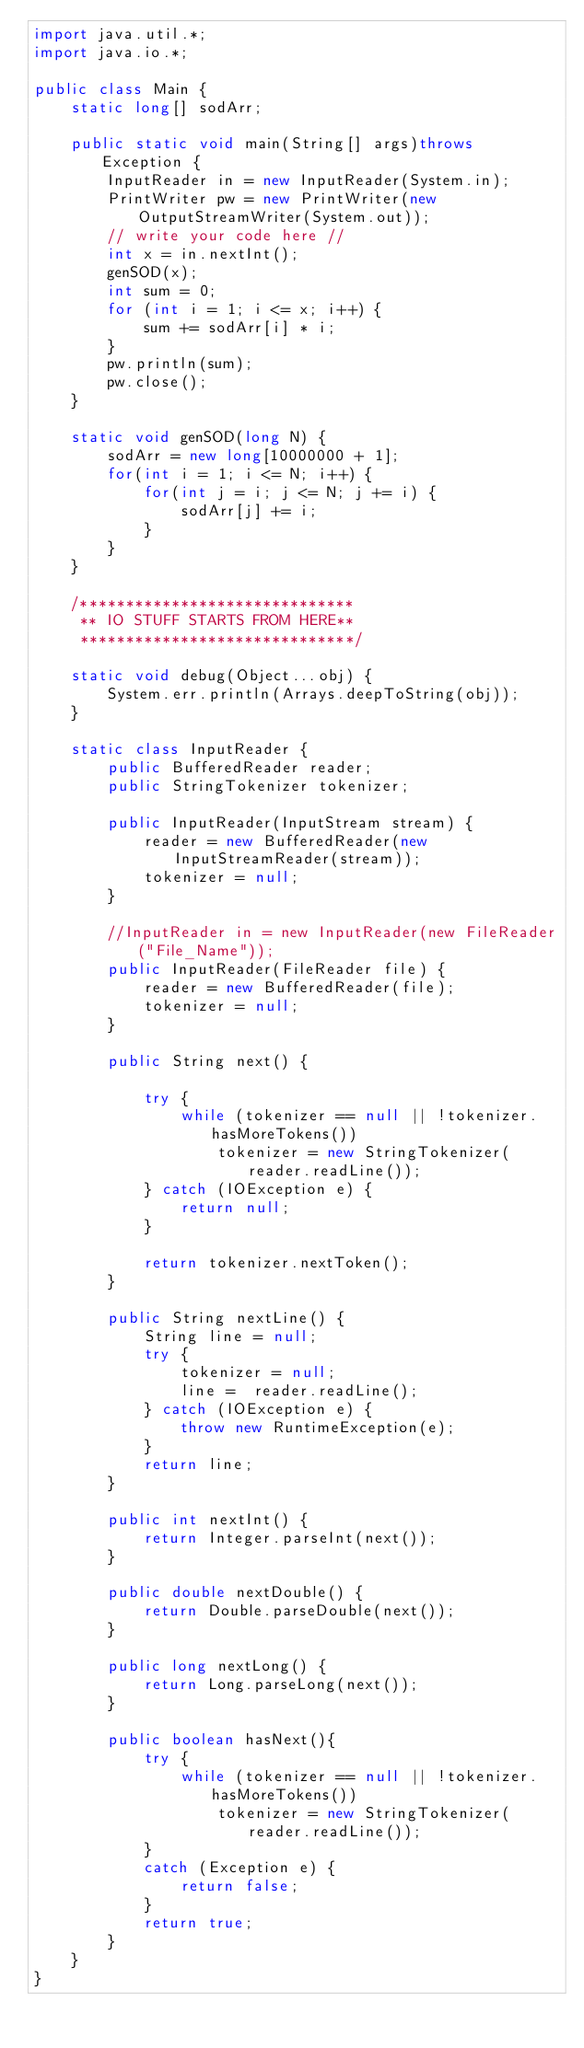<code> <loc_0><loc_0><loc_500><loc_500><_Java_>import java.util.*;
import java.io.*;

public class Main {
    static long[] sodArr;
    
    public static void main(String[] args)throws Exception {
        InputReader in = new InputReader(System.in);
        PrintWriter pw = new PrintWriter(new OutputStreamWriter(System.out));
        // write your code here //
        int x = in.nextInt();
        genSOD(x);
        int sum = 0;
        for (int i = 1; i <= x; i++) {
            sum += sodArr[i] * i;
        }
        pw.println(sum);
        pw.close();
    }
    
    static void genSOD(long N) {
        sodArr = new long[10000000 + 1];
        for(int i = 1; i <= N; i++) {
            for(int j = i; j <= N; j += i) {
                sodArr[j] += i;
            }
        }
    }

    /******************************
     ** IO STUFF STARTS FROM HERE**
     ******************************/

    static void debug(Object...obj) {
        System.err.println(Arrays.deepToString(obj));
    }

    static class InputReader {
        public BufferedReader reader;
        public StringTokenizer tokenizer;

        public InputReader(InputStream stream) {
            reader = new BufferedReader(new InputStreamReader(stream));
            tokenizer = null;
        }

        //InputReader in = new InputReader(new FileReader("File_Name"));
        public InputReader(FileReader file) {
            reader = new BufferedReader(file);
            tokenizer = null;
        }

        public String next() {

            try {
                while (tokenizer == null || !tokenizer.hasMoreTokens())
                    tokenizer = new StringTokenizer(reader.readLine());
            } catch (IOException e) {
                return null;
            }

            return tokenizer.nextToken();
        }

        public String nextLine() {
            String line = null;
            try {
                tokenizer = null;
                line =  reader.readLine();
            } catch (IOException e) {
                throw new RuntimeException(e);
            }
            return line;
        }

        public int nextInt() {
            return Integer.parseInt(next());
        }

        public double nextDouble() {
            return Double.parseDouble(next());
        }

        public long nextLong() {
            return Long.parseLong(next());
        }

        public boolean hasNext(){
            try {
                while (tokenizer == null || !tokenizer.hasMoreTokens())
                    tokenizer = new StringTokenizer(reader.readLine());
            }
            catch (Exception e) {
                return false;
            }
            return true;
        }
    }
}</code> 